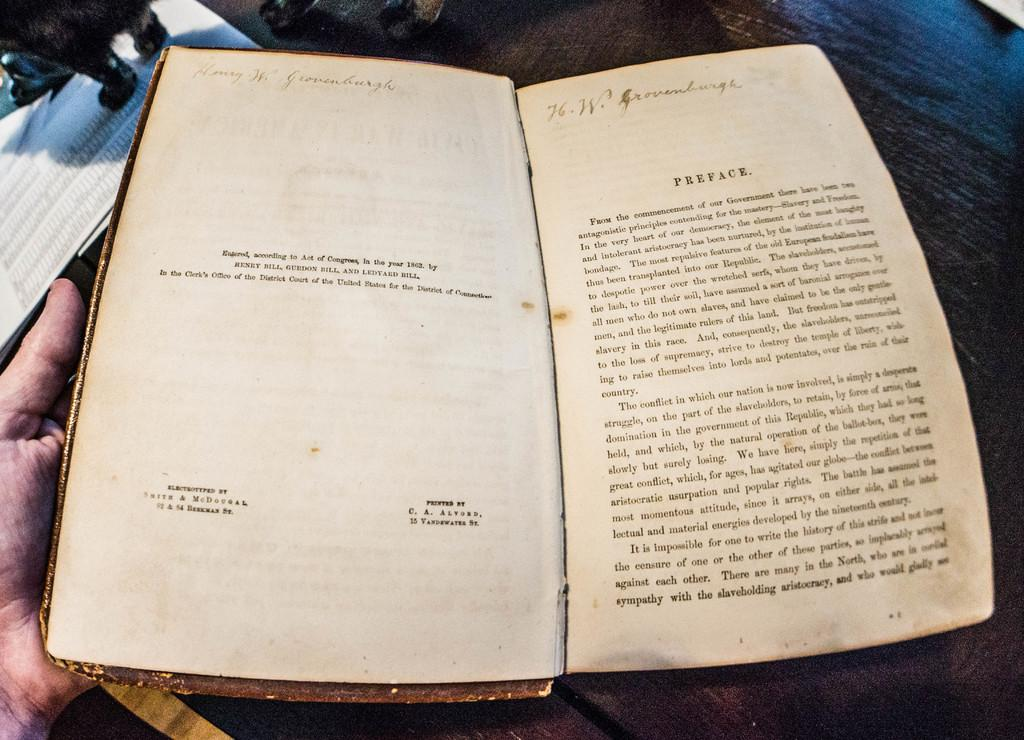<image>
Provide a brief description of the given image. The preface of an ancient book is opened to page 2 